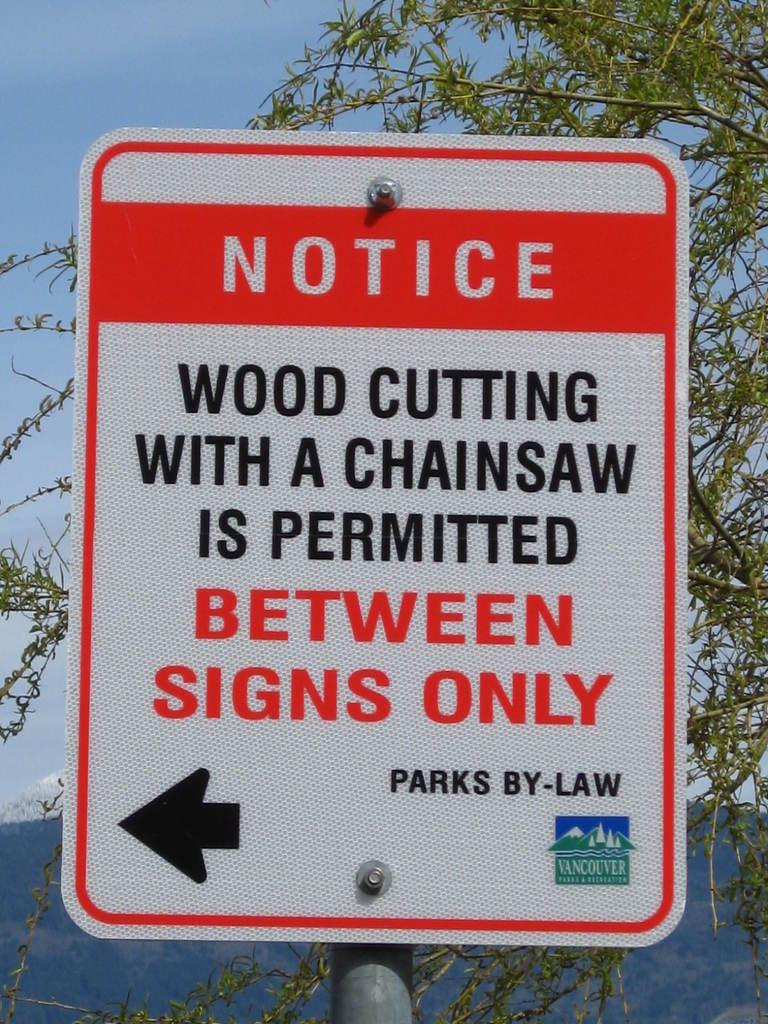Provide a one-sentence caption for the provided image. A notice sign outdoors reads notice wood cutting with a chainsaw is permitted between signs only. 